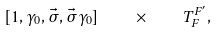<formula> <loc_0><loc_0><loc_500><loc_500>[ 1 , \gamma _ { 0 } , \vec { \sigma } , \vec { \sigma } \gamma _ { 0 } ] \quad \times \quad T _ { F } ^ { F ^ { \prime } } ,</formula> 